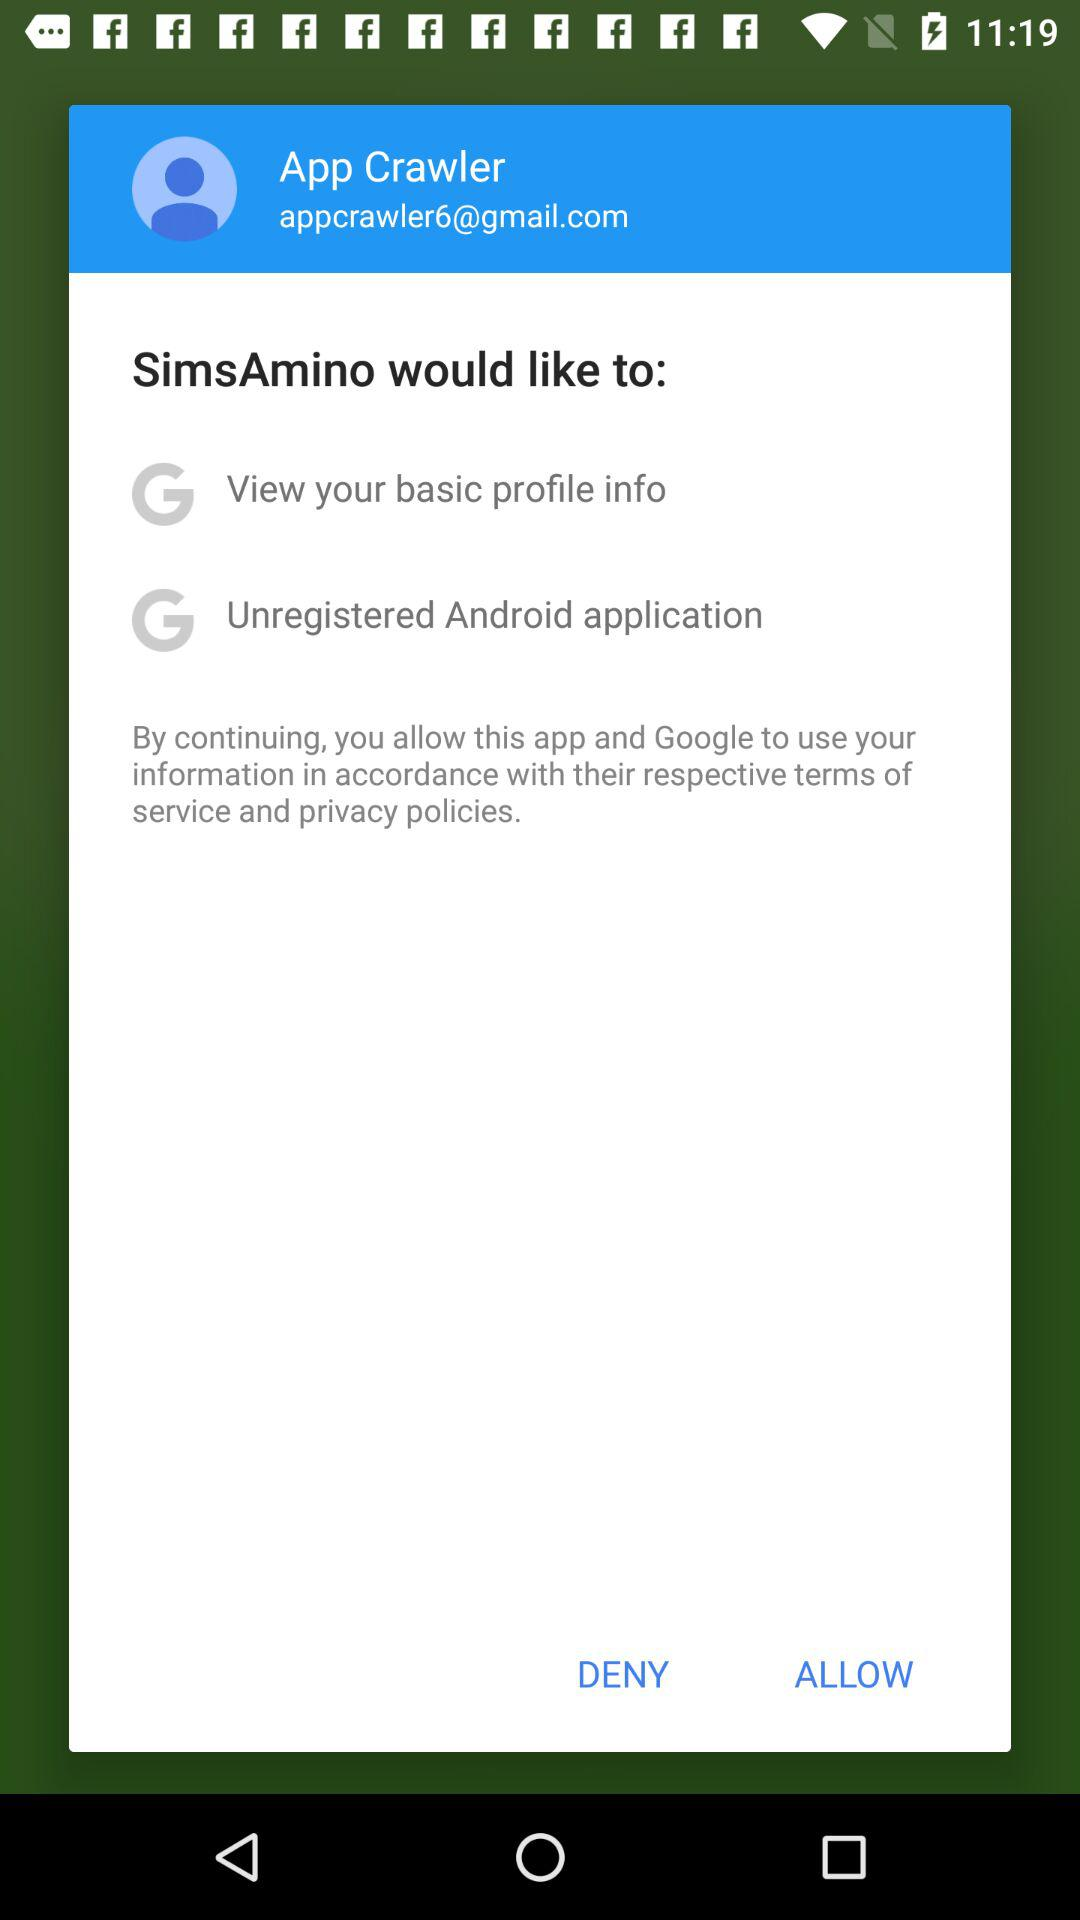How many permissions does SimsAmino ask for?
Answer the question using a single word or phrase. 2 